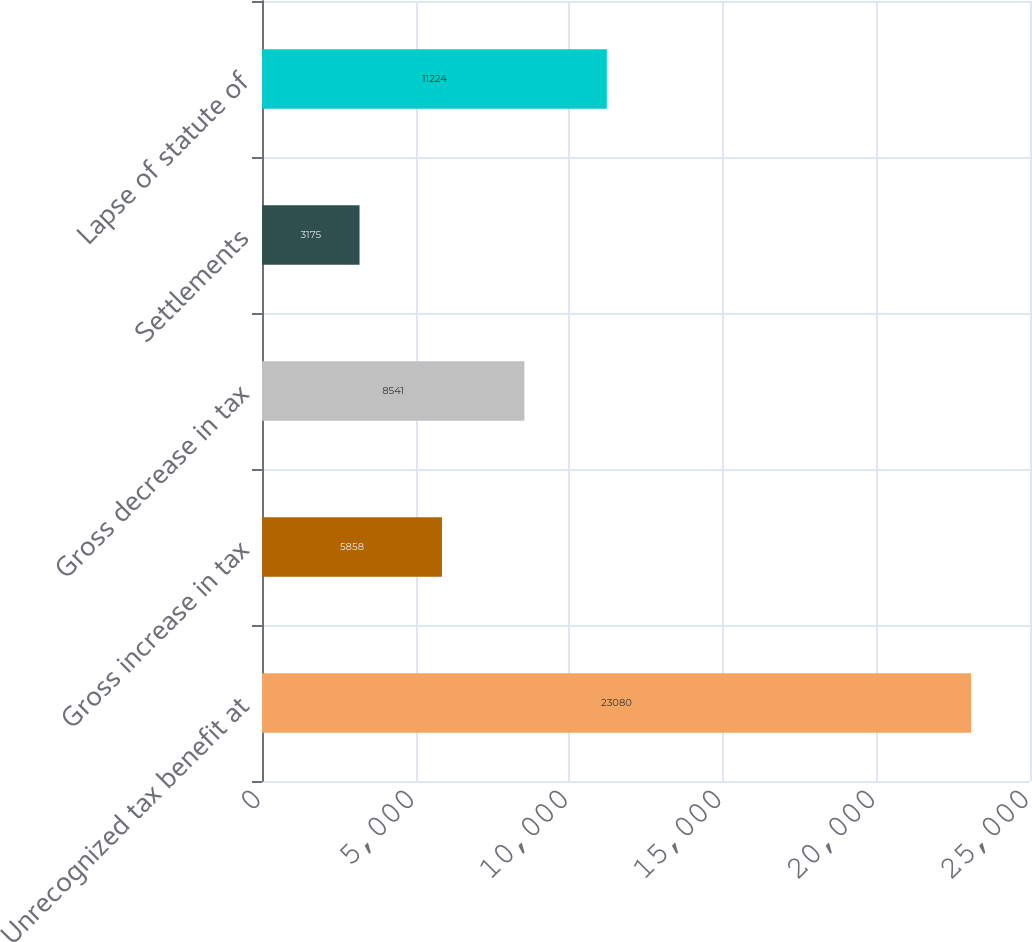Convert chart to OTSL. <chart><loc_0><loc_0><loc_500><loc_500><bar_chart><fcel>Unrecognized tax benefit at<fcel>Gross increase in tax<fcel>Gross decrease in tax<fcel>Settlements<fcel>Lapse of statute of<nl><fcel>23080<fcel>5858<fcel>8541<fcel>3175<fcel>11224<nl></chart> 